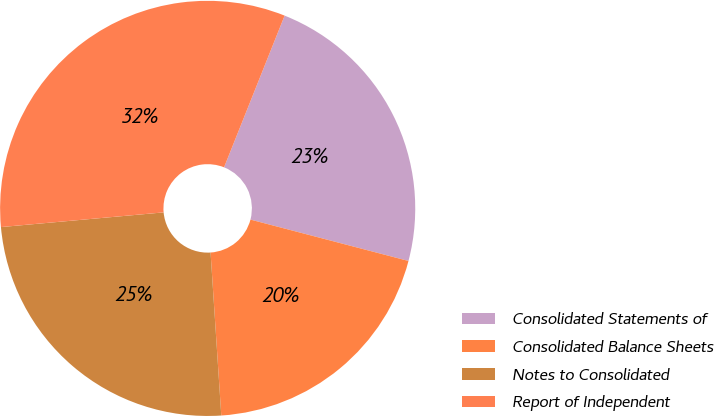<chart> <loc_0><loc_0><loc_500><loc_500><pie_chart><fcel>Consolidated Statements of<fcel>Consolidated Balance Sheets<fcel>Notes to Consolidated<fcel>Report of Independent<nl><fcel>23.03%<fcel>19.88%<fcel>24.61%<fcel>32.48%<nl></chart> 